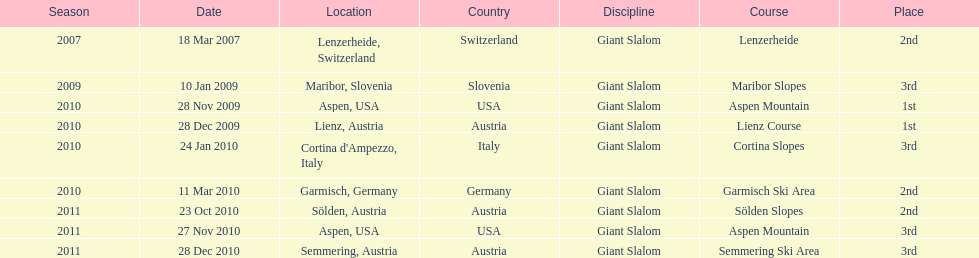What is the total number of her 2nd place finishes on the list? 3. 